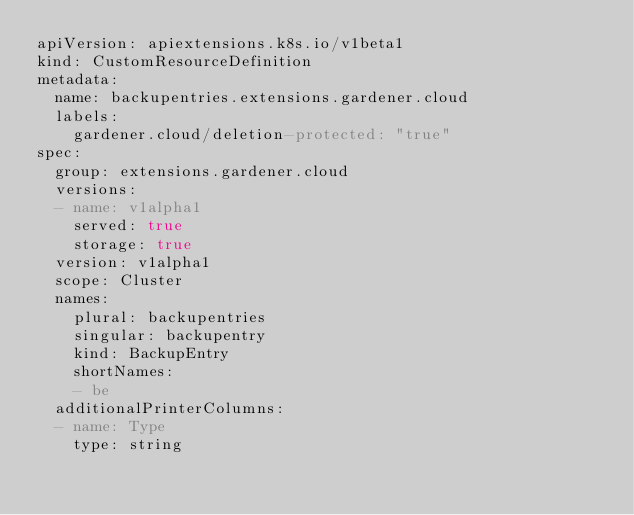<code> <loc_0><loc_0><loc_500><loc_500><_YAML_>apiVersion: apiextensions.k8s.io/v1beta1
kind: CustomResourceDefinition
metadata:
  name: backupentries.extensions.gardener.cloud
  labels:
    gardener.cloud/deletion-protected: "true"
spec:
  group: extensions.gardener.cloud
  versions:
  - name: v1alpha1
    served: true
    storage: true
  version: v1alpha1
  scope: Cluster
  names:
    plural: backupentries
    singular: backupentry
    kind: BackupEntry
    shortNames:
    - be
  additionalPrinterColumns:
  - name: Type
    type: string</code> 